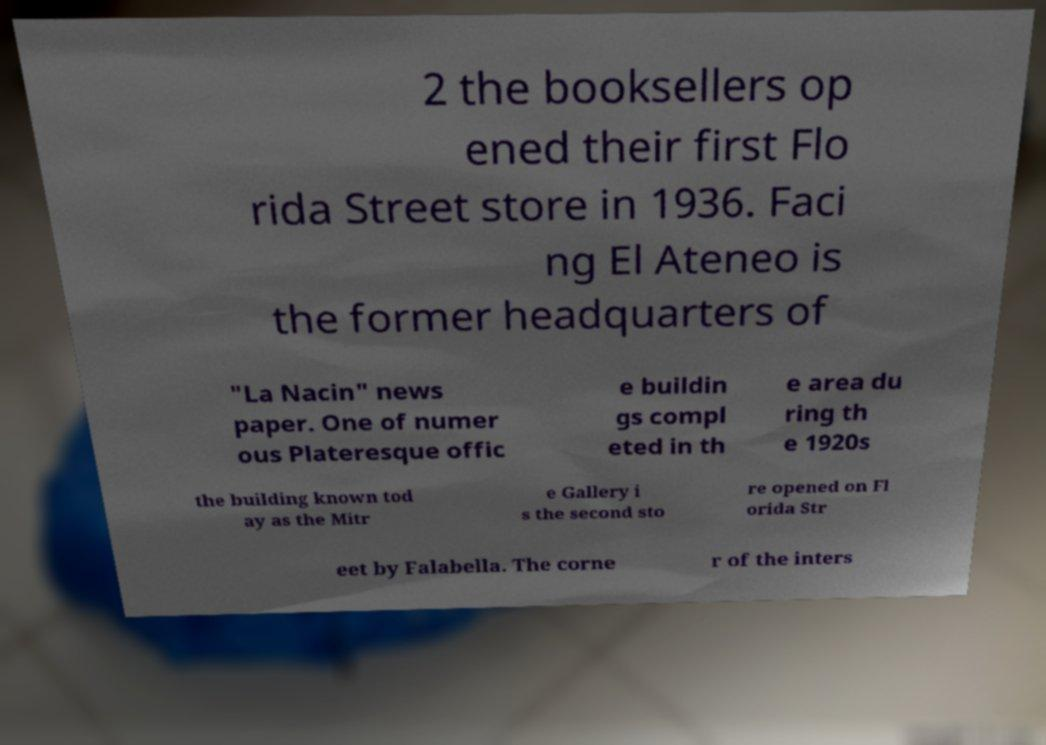There's text embedded in this image that I need extracted. Can you transcribe it verbatim? 2 the booksellers op ened their first Flo rida Street store in 1936. Faci ng El Ateneo is the former headquarters of "La Nacin" news paper. One of numer ous Plateresque offic e buildin gs compl eted in th e area du ring th e 1920s the building known tod ay as the Mitr e Gallery i s the second sto re opened on Fl orida Str eet by Falabella. The corne r of the inters 